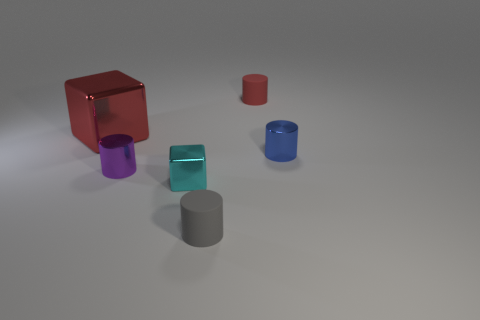Subtract all red cylinders. How many cylinders are left? 3 Subtract all cylinders. How many objects are left? 2 Add 6 tiny blue things. How many tiny blue things exist? 7 Add 1 small blue shiny cylinders. How many objects exist? 7 Subtract 0 red balls. How many objects are left? 6 Subtract 1 cylinders. How many cylinders are left? 3 Subtract all purple cylinders. Subtract all gray blocks. How many cylinders are left? 3 Subtract all brown blocks. How many blue cylinders are left? 1 Subtract all cylinders. Subtract all tiny brown blocks. How many objects are left? 2 Add 1 small objects. How many small objects are left? 6 